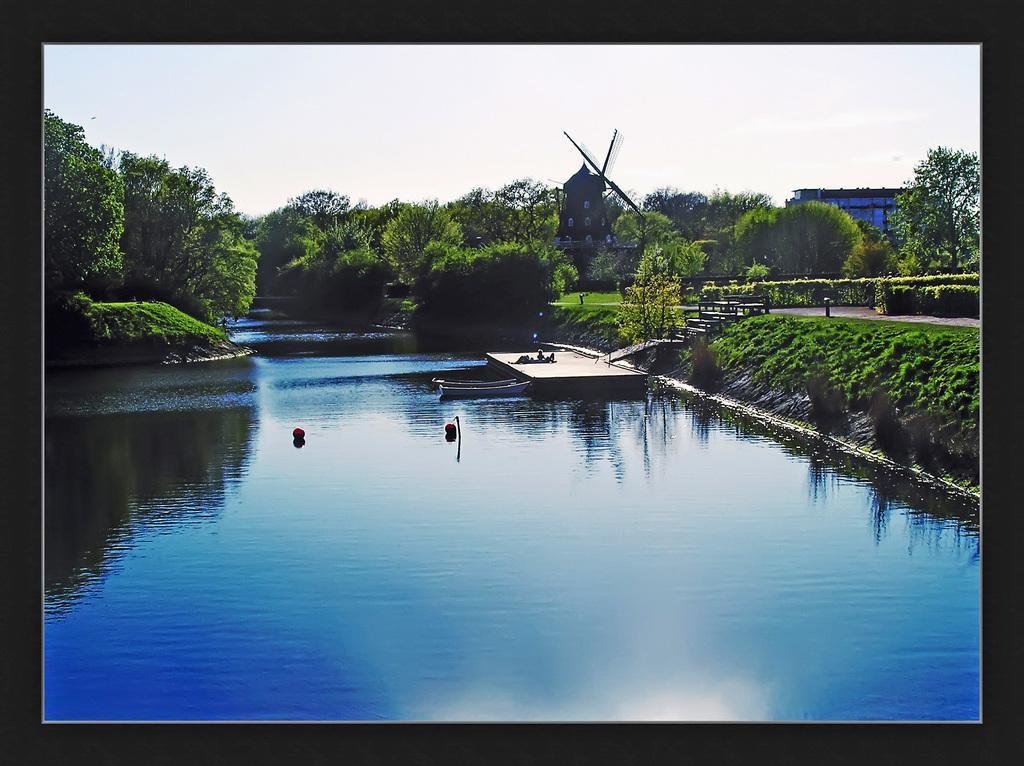Describe this image in one or two sentences. In this picture we can see boats and some objects on the water. On the right side of the boats, it looks like a wooden pier and Behind the wooden pier there are trees, houses and the sky. 